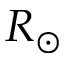<formula> <loc_0><loc_0><loc_500><loc_500>R _ { \odot }</formula> 